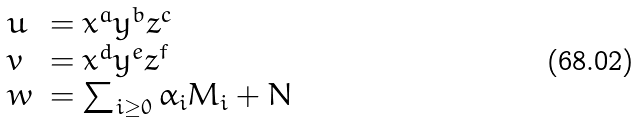<formula> <loc_0><loc_0><loc_500><loc_500>\begin{array} { l l } u & = x ^ { a } y ^ { b } z ^ { c } \\ v & = x ^ { d } y ^ { e } z ^ { f } \\ w & = \sum _ { i \geq 0 } \alpha _ { i } M _ { i } + N \end{array}</formula> 